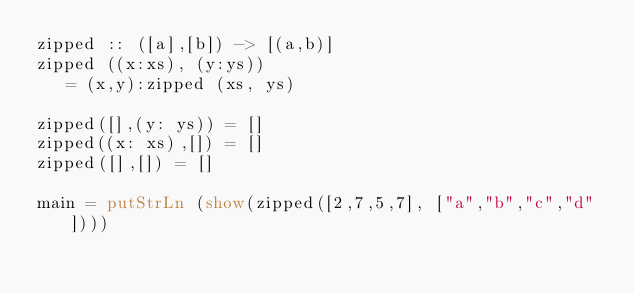<code> <loc_0><loc_0><loc_500><loc_500><_Haskell_>zipped :: ([a],[b]) -> [(a,b)]
zipped ((x:xs), (y:ys)) 
   = (x,y):zipped (xs, ys)

zipped([],(y: ys)) = []
zipped((x: xs),[]) = []
zipped([],[]) = []

main = putStrLn (show(zipped([2,7,5,7], ["a","b","c","d"])))</code> 